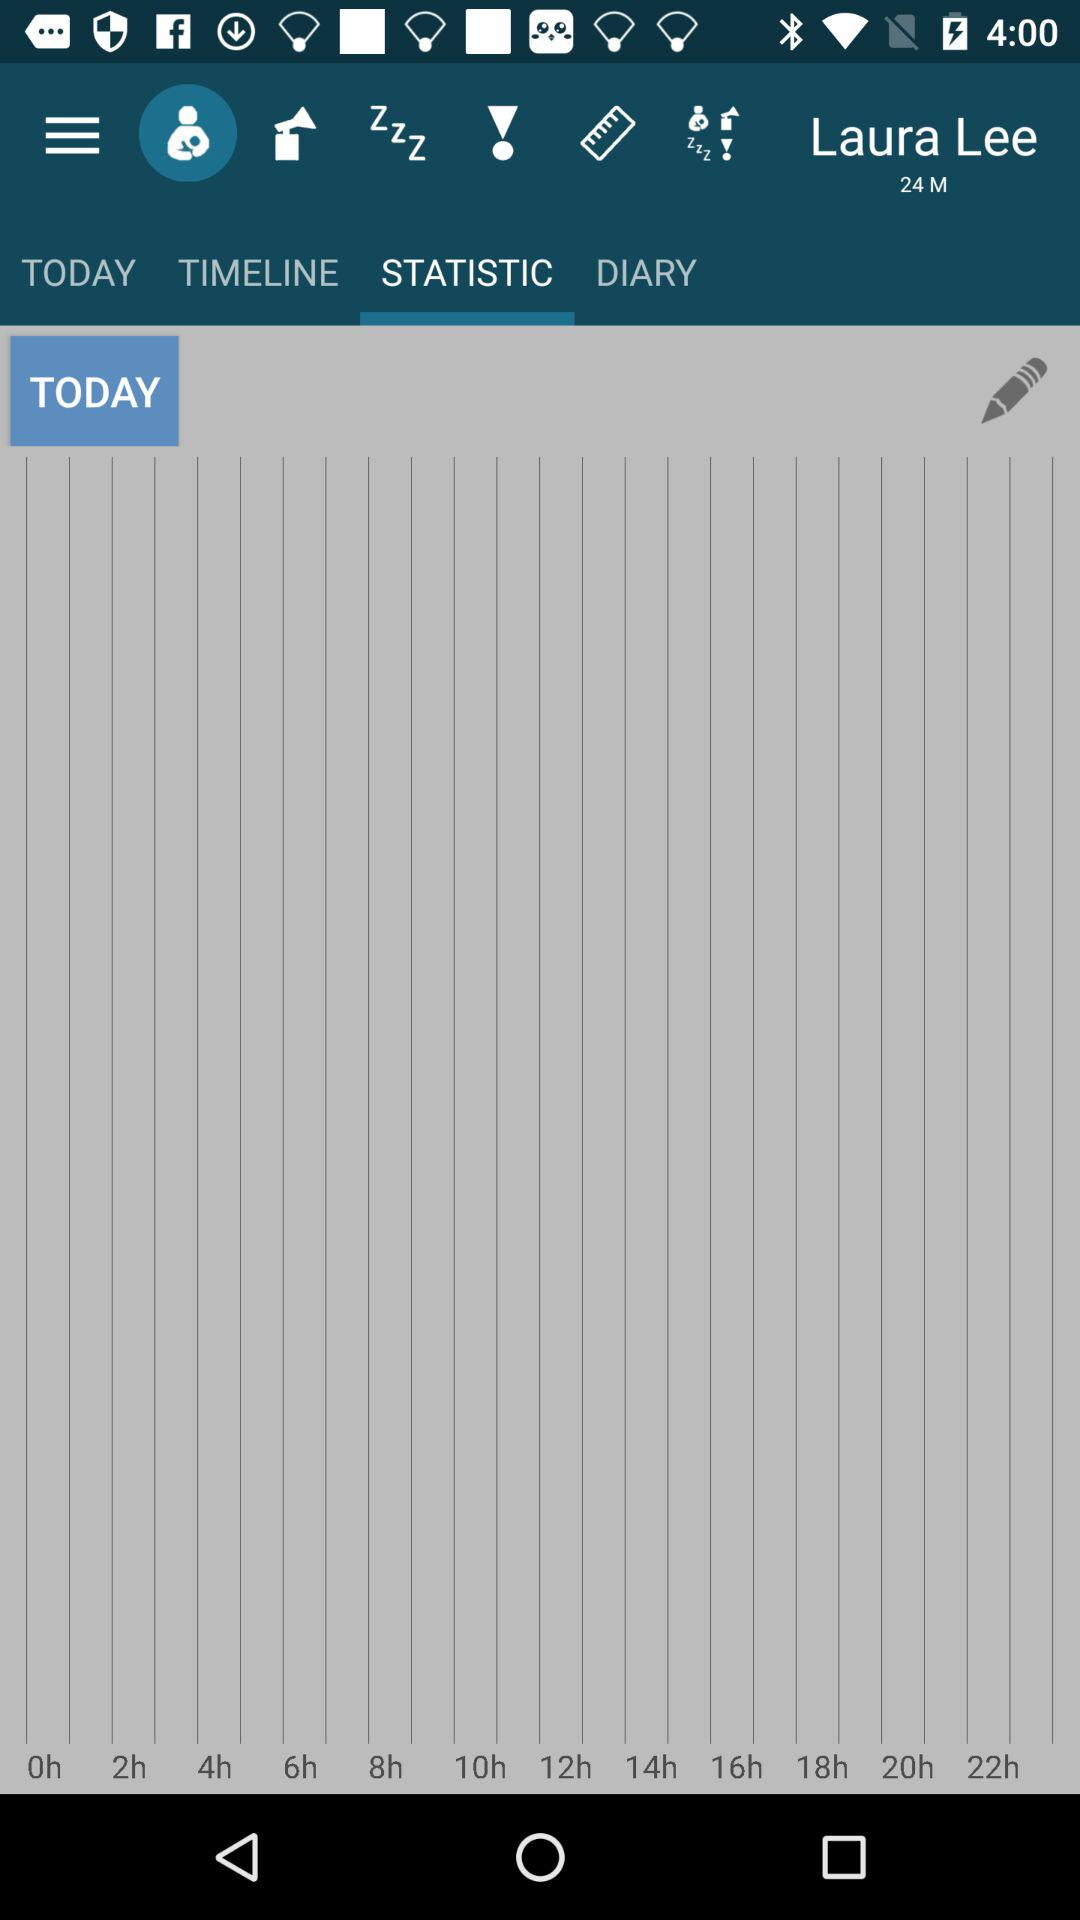What's the username? The username is Laura Lee. 